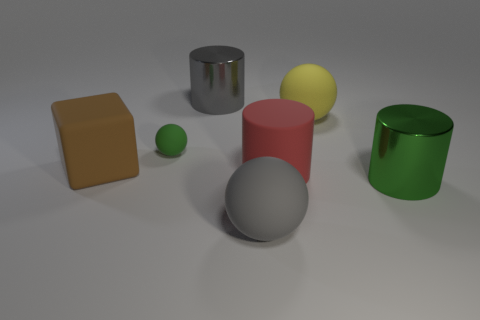Add 3 tiny cyan metallic blocks. How many objects exist? 10 Subtract all cubes. How many objects are left? 6 Add 5 gray shiny cylinders. How many gray shiny cylinders are left? 6 Add 3 large purple cylinders. How many large purple cylinders exist? 3 Subtract 0 purple cubes. How many objects are left? 7 Subtract all green spheres. Subtract all big gray matte balls. How many objects are left? 5 